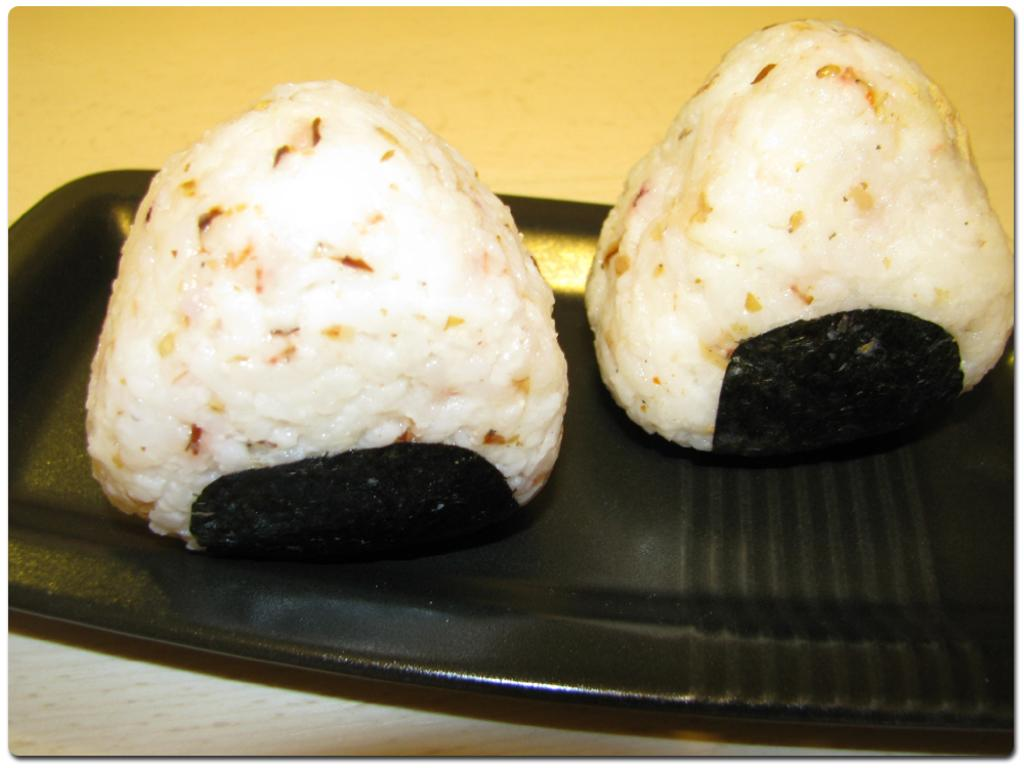What is present in the image related to food? There are food items in the image. How are the food items arranged or presented? The food items are placed on a tray. What is the color of the tray? The tray is black in color. Can you see any ants crawling on the food items in the image? There are no ants visible in the image. Is there a kitten playing with the food items in the image? There is no kitten present in the image. 